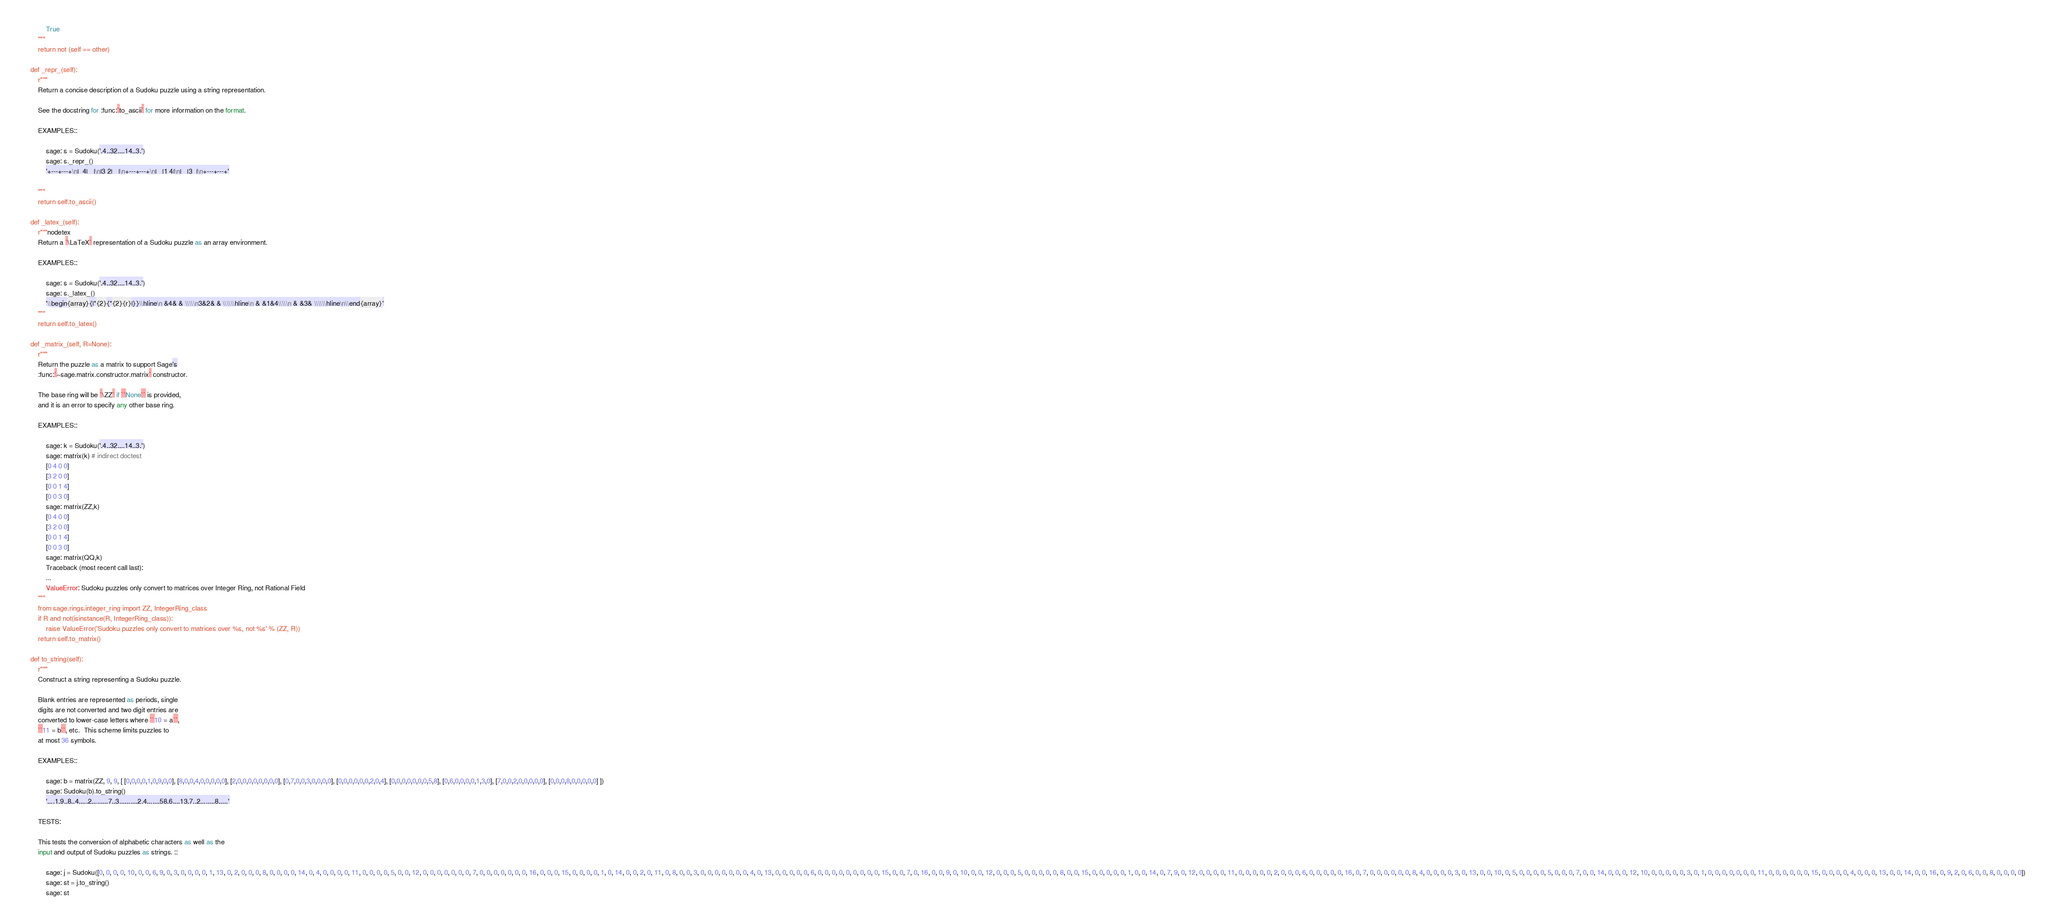<code> <loc_0><loc_0><loc_500><loc_500><_Python_>            True
        """
        return not (self == other)

    def _repr_(self):
        r"""
        Return a concise description of a Sudoku puzzle using a string representation.

        See the docstring for :func:`to_ascii` for more information on the format.

        EXAMPLES::

            sage: s = Sudoku('.4..32....14..3.')
            sage: s._repr_()
            '+---+---+\n|  4|   |\n|3 2|   |\n+---+---+\n|   |1 4|\n|   |3  |\n+---+---+'

        """
        return self.to_ascii()

    def _latex_(self):
        r"""nodetex
        Return a `\LaTeX` representation of a Sudoku puzzle as an array environment.

        EXAMPLES::

            sage: s = Sudoku('.4..32....14..3.')
            sage: s._latex_()
            '\\begin{array}{|*{2}{*{2}{r}|}}\\hline\n &4& & \\\\\n3&2& & \\\\\\hline\n & &1&4\\\\\n & &3& \\\\\\hline\n\\end{array}'
        """
        return self.to_latex()

    def _matrix_(self, R=None):
        r"""
        Return the puzzle as a matrix to support Sage's
        :func:`~sage.matrix.constructor.matrix` constructor.

        The base ring will be `\ZZ` if ``None`` is provided,
        and it is an error to specify any other base ring.

        EXAMPLES::

            sage: k = Sudoku('.4..32....14..3.')
            sage: matrix(k) # indirect doctest
            [0 4 0 0]
            [3 2 0 0]
            [0 0 1 4]
            [0 0 3 0]
            sage: matrix(ZZ,k)
            [0 4 0 0]
            [3 2 0 0]
            [0 0 1 4]
            [0 0 3 0]
            sage: matrix(QQ,k)
            Traceback (most recent call last):
            ...
            ValueError: Sudoku puzzles only convert to matrices over Integer Ring, not Rational Field
        """
        from sage.rings.integer_ring import ZZ, IntegerRing_class
        if R and not(isinstance(R, IntegerRing_class)):
            raise ValueError('Sudoku puzzles only convert to matrices over %s, not %s' % (ZZ, R))
        return self.to_matrix()

    def to_string(self):
        r"""
        Construct a string representing a Sudoku puzzle.

        Blank entries are represented as periods, single
        digits are not converted and two digit entries are
        converted to lower-case letters where ``10 = a``,
        ``11 = b``, etc.  This scheme limits puzzles to
        at most 36 symbols.

        EXAMPLES::

            sage: b = matrix(ZZ, 9, 9, [ [0,0,0,0,1,0,9,0,0], [8,0,0,4,0,0,0,0,0], [2,0,0,0,0,0,0,0,0], [0,7,0,0,3,0,0,0,0], [0,0,0,0,0,0,2,0,4], [0,0,0,0,0,0,0,5,8], [0,6,0,0,0,0,1,3,0], [7,0,0,2,0,0,0,0,0], [0,0,0,8,0,0,0,0,0] ])
            sage: Sudoku(b).to_string()
            '....1.9..8..4.....2.........7..3..........2.4.......58.6....13.7..2........8.....'

        TESTS:

        This tests the conversion of alphabetic characters as well as the
        input and output of Sudoku puzzles as strings. ::

            sage: j = Sudoku([0, 0, 0, 0, 10, 0, 0, 6, 9, 0, 3, 0, 0, 0, 0, 1, 13, 0, 2, 0, 0, 0, 8, 0, 0, 0, 0, 14, 0, 4, 0, 0, 0, 0, 11, 0, 0, 0, 0, 5, 0, 0, 12, 0, 0, 0, 0, 0, 0, 0, 7, 0, 0, 0, 0, 0, 0, 0, 16, 0, 0, 0, 15, 0, 0, 0, 0, 1, 0, 14, 0, 0, 2, 0, 11, 0, 8, 0, 0, 3, 0, 0, 0, 0, 0, 0, 0, 4, 0, 13, 0, 0, 0, 0, 0, 6, 0, 0, 0, 0, 0, 0, 0, 0, 0, 15, 0, 0, 7, 0, 16, 0, 0, 9, 0, 10, 0, 0, 12, 0, 0, 0, 5, 0, 0, 0, 0, 0, 8, 0, 0, 15, 0, 0, 0, 0, 0, 1, 0, 0, 14, 0, 7, 9, 0, 12, 0, 0, 0, 0, 11, 0, 0, 0, 0, 0, 2, 0, 0, 0, 6, 0, 0, 0, 0, 0, 16, 0, 7, 0, 0, 0, 0, 0, 0, 8, 4, 0, 0, 0, 0, 3, 0, 13, 0, 0, 10, 0, 5, 0, 0, 0, 0, 5, 0, 0, 0, 7, 0, 0, 14, 0, 0, 0, 12, 10, 0, 0, 0, 0, 0, 3, 0, 1, 0, 0, 0, 0, 0, 0, 0, 11, 0, 0, 0, 0, 0, 0, 15, 0, 0, 0, 0, 4, 0, 0, 0, 13, 0, 0, 14, 0, 0, 16, 0, 9, 2, 0, 6, 0, 0, 8, 0, 0, 0, 0])
            sage: st = j.to_string()
            sage: st</code> 